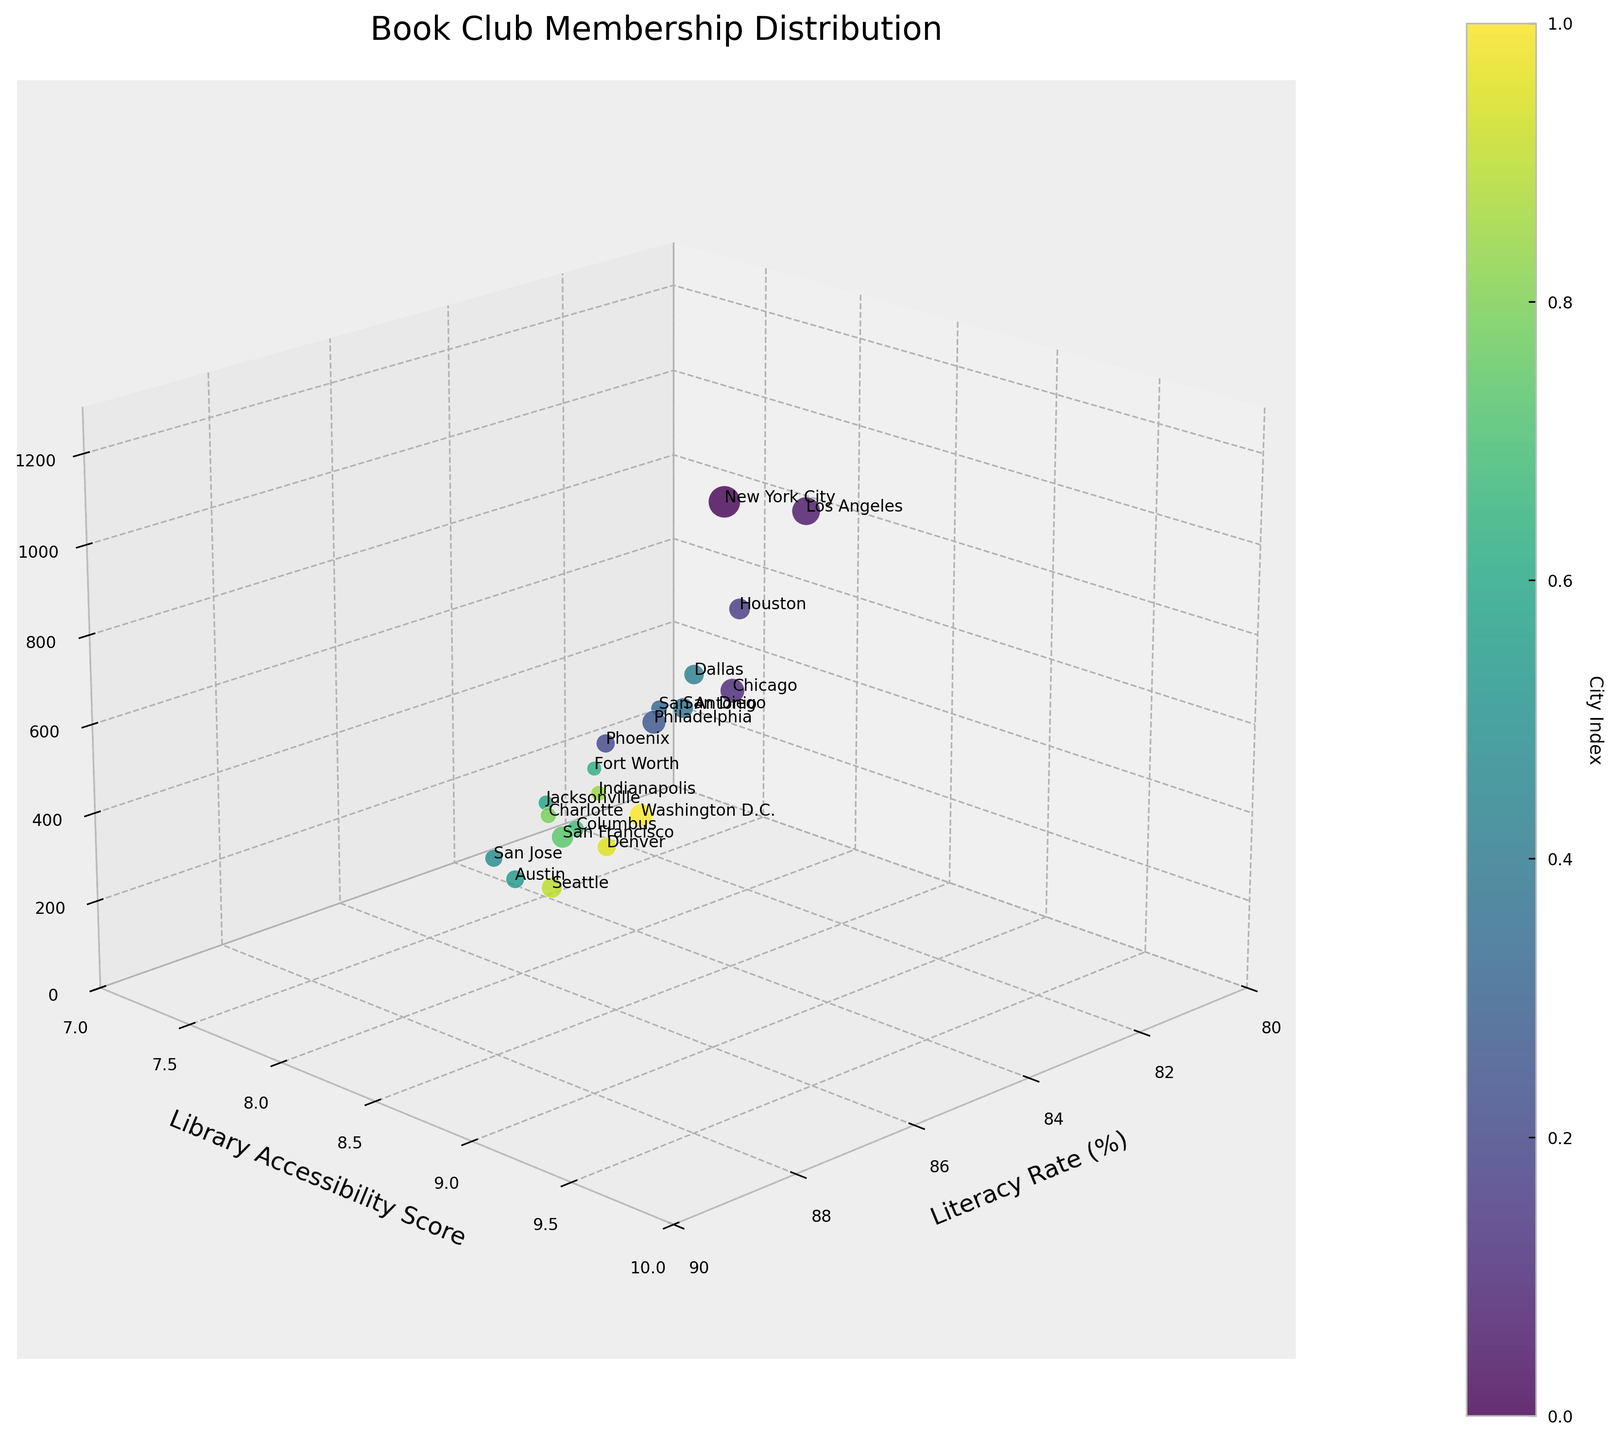What's the title of the figure? The title is prominently displayed at the top of the figure and provides a summary of what the visual data represents.
Answer: Book Club Membership Distribution What is the range of the Literacy Rate axis? The ranges of the axes can be determined by looking at the labels and ticks. The Literacy Rate axis ranges from 80 to 90.
Answer: 80 to 90 How many cities have more than 500 book club members? By identifying the data points (cities) with the z-value (Book Club Members) greater than 500, we can count the cities. They are New York City, Los Angeles, Chicago, Philadelphia, San Francisco, and Seattle. That's 6 cities.
Answer: 6 Which city has the lowest literacy rate? We look at the data points closest to the minimum on the Literacy Rate axis (x-axis). Houston is at 80.8%, which is the lowest.
Answer: Houston What's the average Library Accessibility Score of all the cities? Sum up all the Library Accessibility Scores and divide by the number of cities. Sum = 9.2 + 8.5 + 8.8 + 7.6 + 7.9 + 8.7 + 7.4 + 8.1 + 7.8 + 8.3 + 8.6 + 7.7 + 7.5 + 8.2 + 9.0 + 7.9 + 7.8 + 9.1 + 8.7 + 9.3 = 171.5. There are 20 cities. So 171.5 / 20 = 8.575.
Answer: 8.575 Which has a greater number of book club members, San Diego or Dallas? Compare the z-values (Book Club Members) of San Diego and Dallas. San Diego has 510 and Dallas has 490.
Answer: San Diego What’s the relationship between literacy rate and book club memberships? Observing the 3D scatter plot, a general trend can be seen where cities with higher literacy rates generally have more book club members, indicating a positive correlation.
Answer: Positive correlation Which city has the highest library accessibility score and how many book club members does it have? We look at the data point with the highest value on the Library Accessibility Score axis (y-axis). Washington D.C. has a score of 9.3, and it has 670 book club members.
Answer: Washington D.C., 670 What is the geographical feature with the highest number of book club members? Observing the data points, the highest z-value (Book Club Members) is from New York City, represented by the highest point in the plot.
Answer: New York City How do the library accessibility scores and literacy rates compare between Seattle and San Francisco? Look at the y-axis and x-axis values for each city. Seattle has a literacy rate of 89.0% and a library accessibility score of 9.1. San Francisco has a literacy rate of 88.5% and a library accessibility score of 9.0.
Answer: Seattle: 89.0%, 9.1; San Francisco: 88.5%, 9.0 